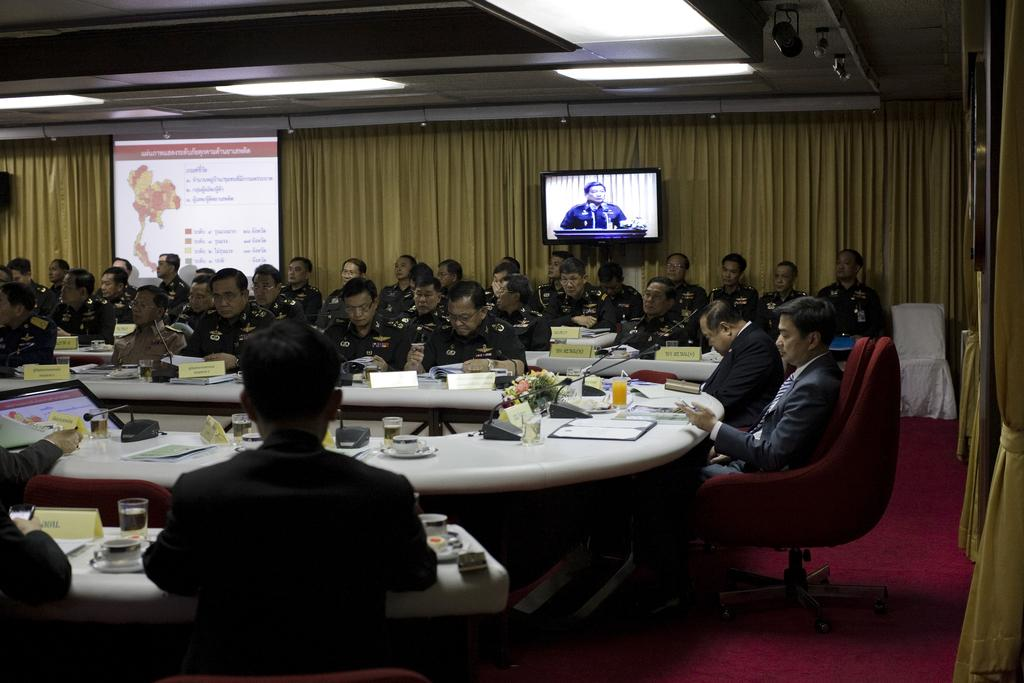How many people are in the image? There is a group of people in the image. What are the people doing in the image? The people are sitting on a chair in the image. What electronic device is present in the image? There is a television in the image. What feature does the television have? The television has a screen. How many icicles can be seen hanging from the television in the image? There are no icicles present in the image, and the television is not outdoors where icicles would form. 